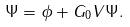<formula> <loc_0><loc_0><loc_500><loc_500>\Psi = \phi + G _ { 0 } V \Psi .</formula> 